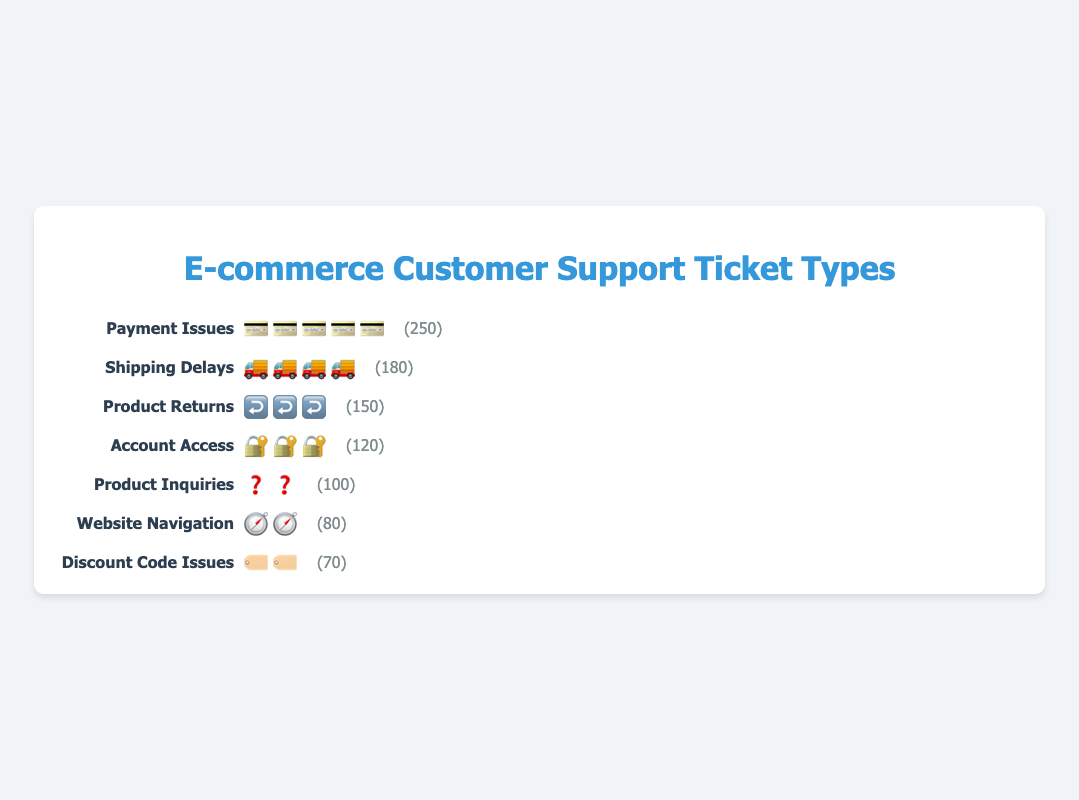What is the title of the figure? The title is usually at the top, set off by larger or bold font. Here, it is centered and colored in #3498db (blue).
Answer: E-commerce Customer Support Ticket Types Which customer support ticket type has the highest frequency? Identify the ticket type with the most icons or the largest number. "Payment Issues" has the most icons and the highest frequency listed.
Answer: Payment Issues How many ticket types are shown in the figure? Count the distinct ticket types displayed, each represented by a different label or icon.
Answer: 7 What is the total number of tickets for all types combined? Sum the frequencies of all ticket types: 250 + 180 + 150 + 120 + 100 + 80 + 70.
Answer: 950 Which types have a frequency of less than 100? Identify ticket types with a frequency stated as less than 100. "Product Inquiries," "Website Navigation," and "Discount Code Issues" all fit this criterion.
Answer: Product Inquiries, Website Navigation, Discount Code Issues How many more payment issues tickets are there than discount code issues tickets? Subtract the frequency of discount code issues from that of payment issues: 250 - 70.
Answer: 180 What is the average frequency of all ticket types? Calculate the sum of frequencies and divide by the number of ticket types: (250 + 180 + 150 + 120 + 100 + 80 + 70) / 7.
Answer: 135.7 Which ticket type icon appears the most frequently? Compare the number of times each icon is displayed and identify the highest count, associated with payment issues.
Answer: 💳 What percentage of the tickets are related to shipping delays? Calculate the percentage using the formula: (Frequency of shipping delays / Total number of tickets) * 100 = (180 / 950) * 100.
Answer: 18.9% Which two ticket types have frequencies that sum to 300? Identify and sum the frequencies of pairs to find the combination that equals 300: e.g., Product Returns (150) and Account Access (120) sum up to 270, the closest available combination to 300.
Answer: Product Returns (150) + Account Access (120) 